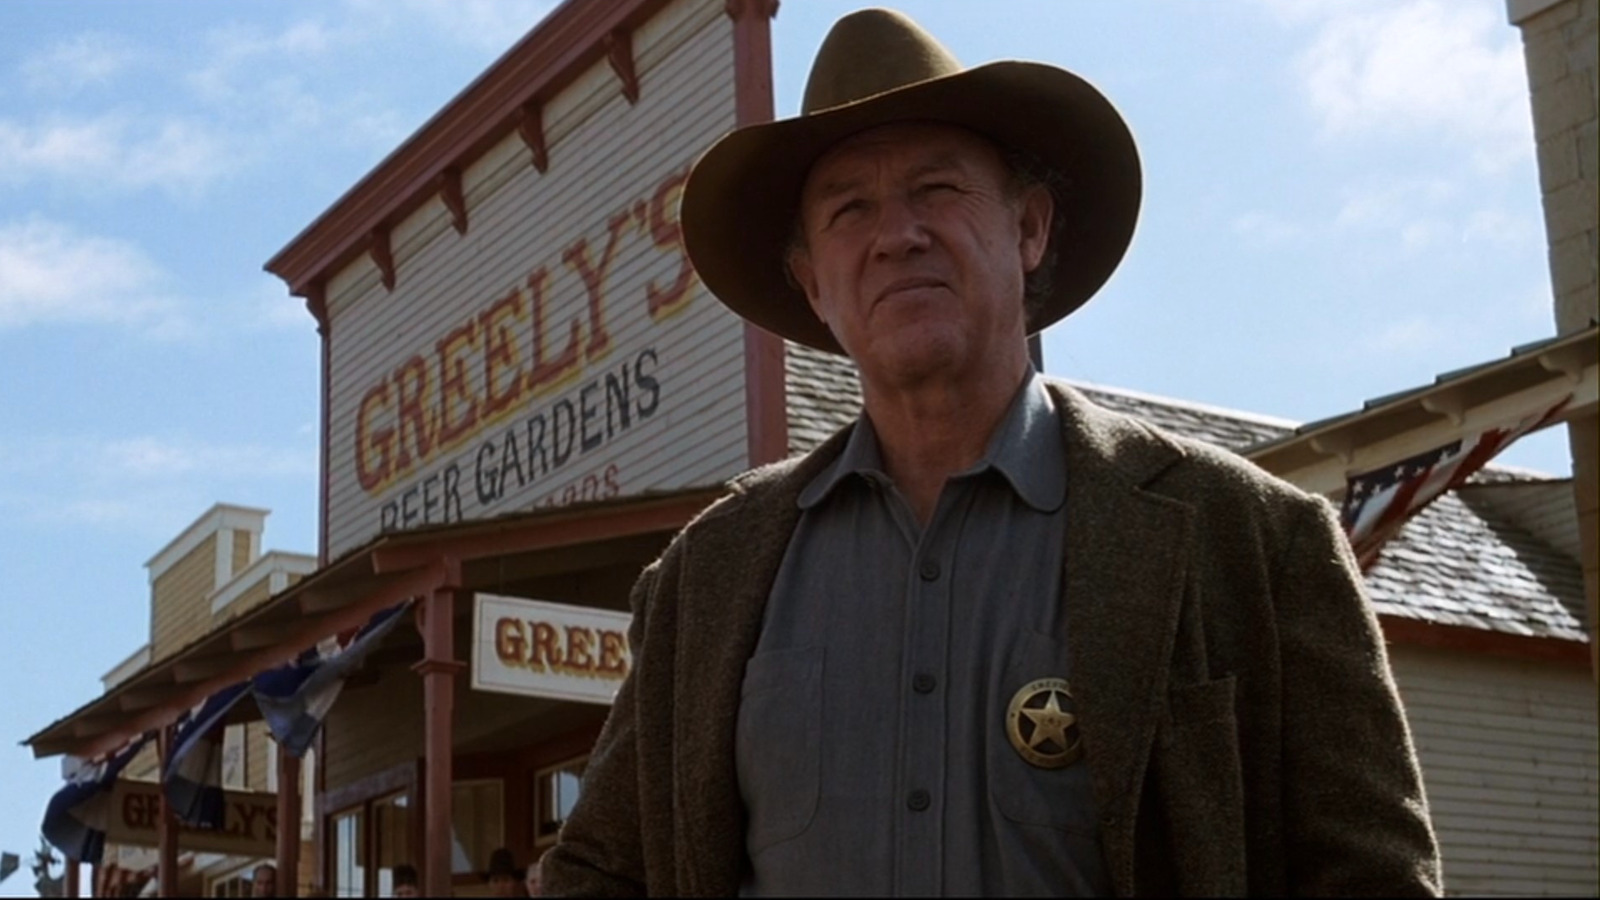What might be the mood or atmosphere conveyed in this image? The mood in the image seems tense and serious. The man's focused expression and the iconic western attire suggest an air of authority and readiness, characteristic of an impending showdown or significant event in a western setting. 